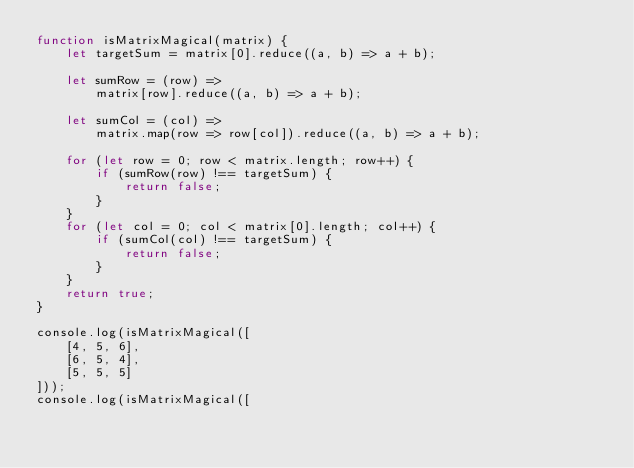<code> <loc_0><loc_0><loc_500><loc_500><_JavaScript_>function isMatrixMagical(matrix) {
    let targetSum = matrix[0].reduce((a, b) => a + b);

    let sumRow = (row) =>
        matrix[row].reduce((a, b) => a + b);

    let sumCol = (col) =>
        matrix.map(row => row[col]).reduce((a, b) => a + b);

    for (let row = 0; row < matrix.length; row++) {
        if (sumRow(row) !== targetSum) {
            return false;
        }
    }
    for (let col = 0; col < matrix[0].length; col++) {
        if (sumCol(col) !== targetSum) {
            return false;
        }
    }
    return true;
}

console.log(isMatrixMagical([
    [4, 5, 6],
    [6, 5, 4],
    [5, 5, 5]
]));
console.log(isMatrixMagical([</code> 